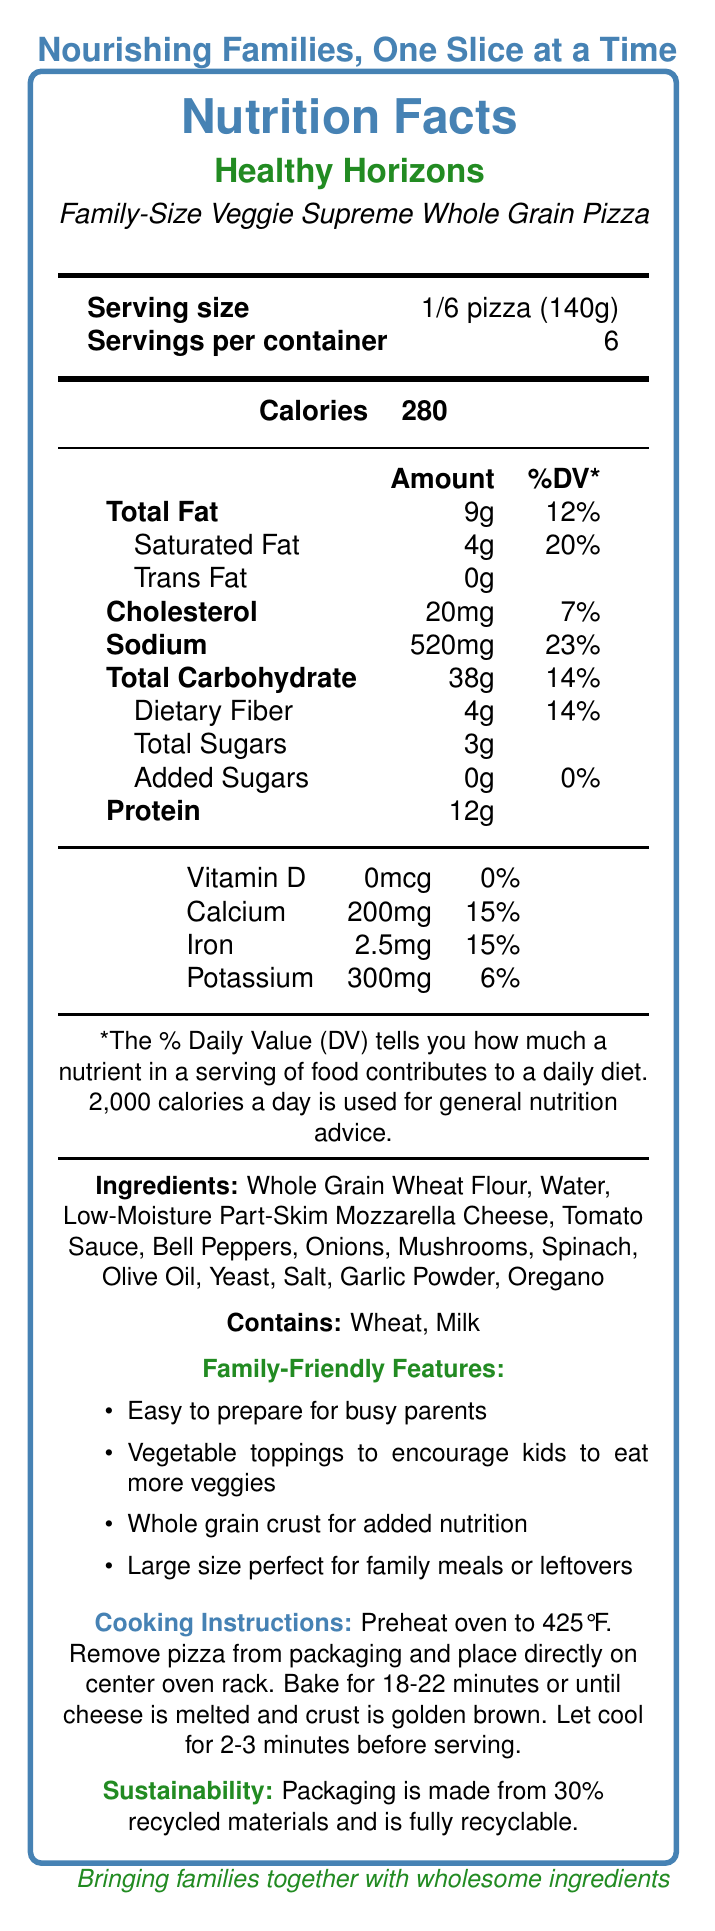what is the serving size of the pizza? The serving size is clearly stated in the section under "Serving size."
Answer: 1/6 pizza (140g) how many servings are in the container? It is explicitly mentioned under "Servings per container."
Answer: 6 what is the amount of saturated fat per serving? The amount of saturated fat per serving is listed in the nutrition details under "Saturated Fat."
Answer: 4g what are the two allergens listed in the document? The allergens are listed at the bottom of the ingredient section with the header "Contains: Wheat, Milk."
Answer: Wheat and Milk how much protein does one serving have? The protein content per serving is listed in the nutrition facts section.
Answer: 12g which of the following is not an ingredient in the pizza? A. Bell Peppers B. Spinach C. Chicken D. Olive Oil The ingredients list mentions Bell Peppers, Spinach, and Olive Oil, but not Chicken.
Answer: C how many calories are in one serving of the pizza? A. 260 B. 280 C. 300 D. 320 The calories per serving are listed in bold in the nutrition facts section and amount to 280.
Answer: B does the pizza contain added sugars? The document lists "Added Sugars" as 0g with 0% Daily Value.
Answer: No is the packaging of the pizza recyclable? The sustainability section at the bottom mentions that the packaging is fully recyclable.
Answer: Yes describe the main idea of the document. The document provides various sections such as nutrition facts, ingredient list, allergens, family-friendly features, cooking instructions, and sustainability details to inform consumers about the product.
Answer: The document is a comprehensive nutrition facts label for a family-sized frozen pizza with a whole grain crust and vegetable toppings by Healthy Horizons, detailing the nutrition information, ingredients, allergens, family-friendly features, cooking instructions, and sustainability information. what is the recommended cooking time for the pizza? The exact cooking time range is given as 18-22 minutes in the cooking instructions, so a specific single value cannot be determined.
Answer: Cannot be determined how many grams of dietary fiber does one serving of pizza have? The amount of dietary fiber per serving is listed under "Dietary Fiber" in the nutrition facts section.
Answer: 4g what percentage of the daily value for sodium does one serving provide? The daily value percentage for sodium per serving is listed under "Sodium" in the nutrition facts section.
Answer: 23% what type of crust does this pizza have? The type of crust is specified in the product name and the family-friendly features section as "whole grain crust."
Answer: Whole grain is this pizza marketed as easy to prepare for parents? Under the family-friendly features, it mentions that the pizza is "Easy to prepare for busy parents."
Answer: Yes what vitamins and minerals are substantially present in one serving of the pizza? The nutrition facts section shows that calcium and iron percentages of the daily value are both 15%, significantly higher than other listed vitamins and minerals.
Answer: Calcium and Iron 